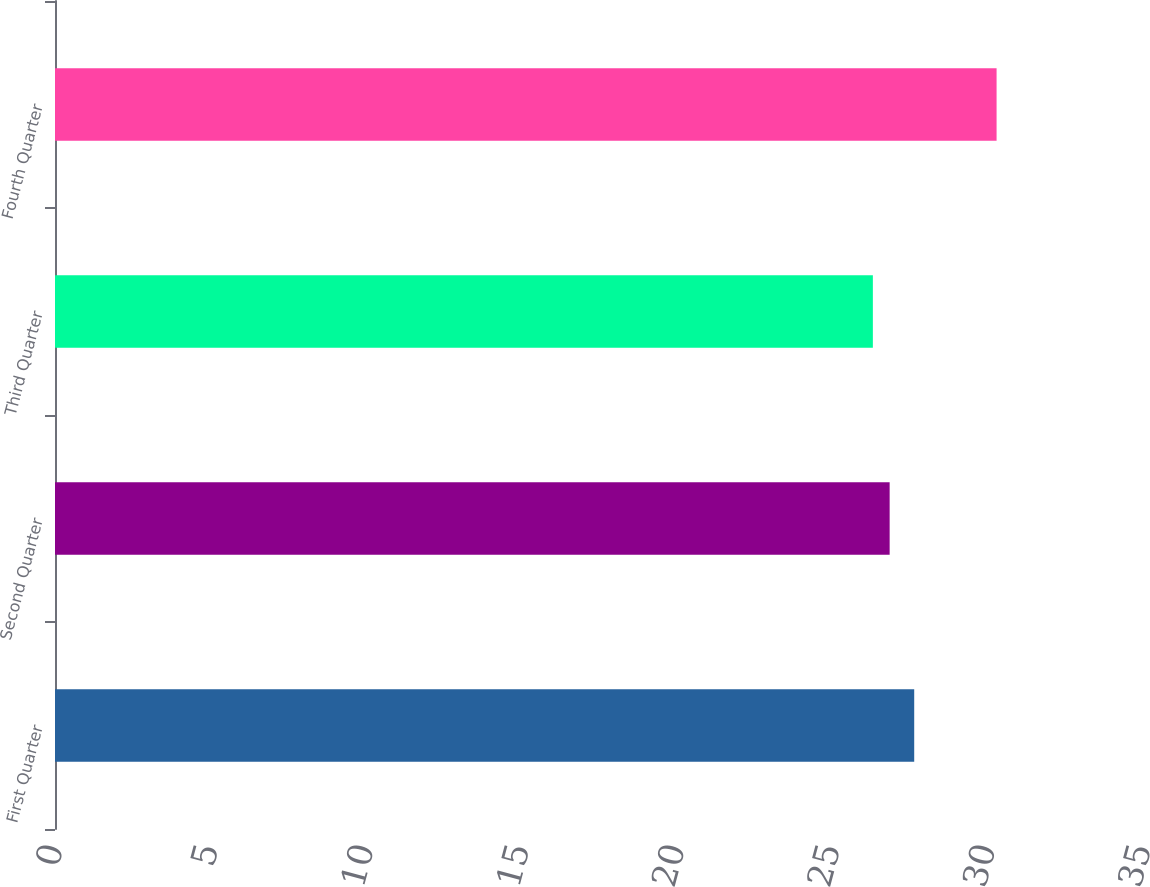Convert chart. <chart><loc_0><loc_0><loc_500><loc_500><bar_chart><fcel>First Quarter<fcel>Second Quarter<fcel>Third Quarter<fcel>Fourth Quarter<nl><fcel>27.64<fcel>26.85<fcel>26.31<fcel>30.29<nl></chart> 